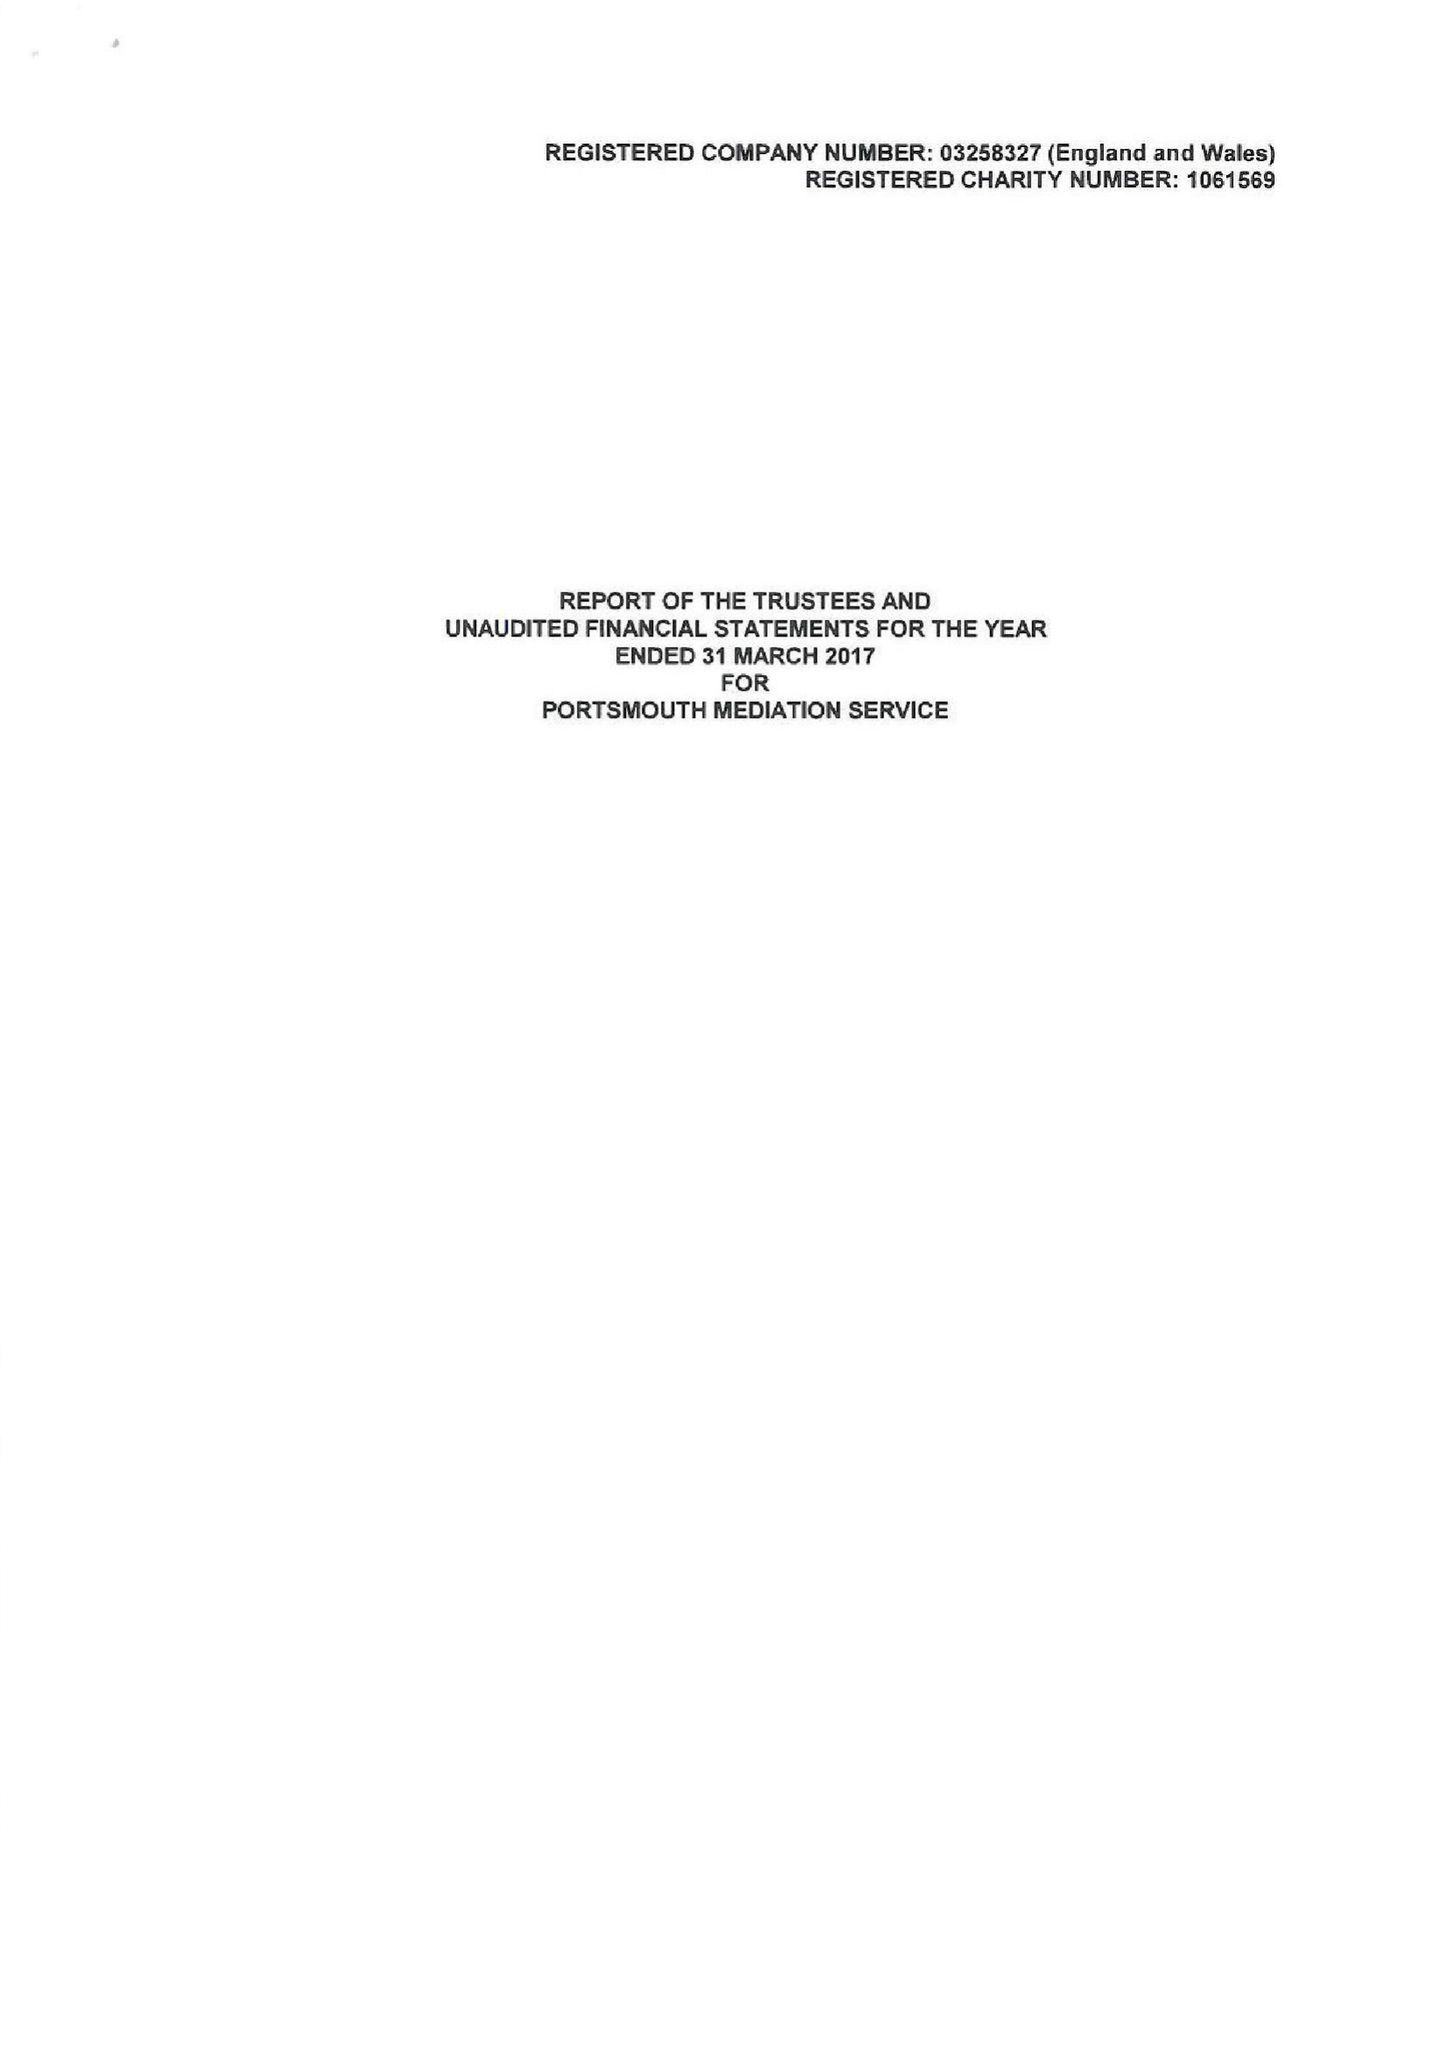What is the value for the address__postcode?
Answer the question using a single word or phrase. PO1 1NP 